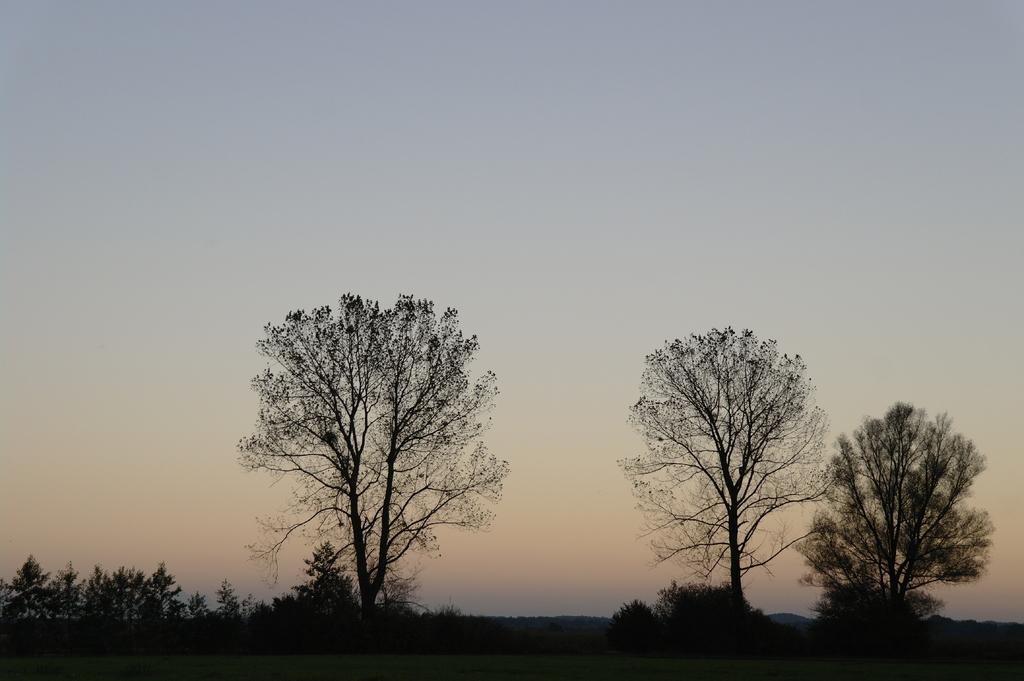What type of vegetation can be seen in the image? There are trees in the image. What is on the ground in the image? There is grass on the ground in the image. What can be seen in the background of the image? There are trees in the background of the image. What is visible in the background of the image? The sky is visible in the background of the image. What type of organization is depicted in the image? There is no organization depicted in the image; it features trees, grass, and the sky. Can you tell me how many jellyfish are swimming in the grass in the image? There are no jellyfish present in the image; it features trees and grass. 